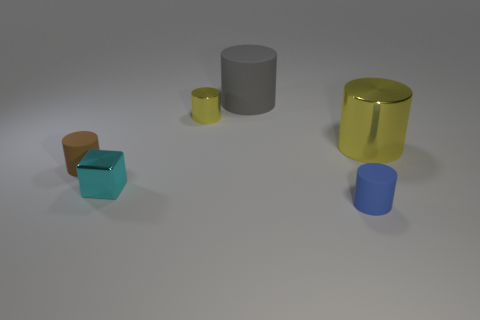Are there more matte or shiny objects in this image? There are more shiny objects in this image. There's a shiny gold cylinder, a smaller yellow cylinder with a reflective surface, and a cyan cube with a gloss finish. In contrast, there's only one matte object, which is the large gray cylinder. 